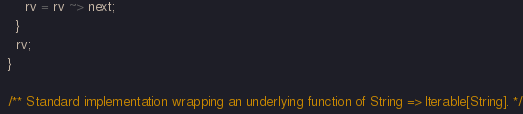<code> <loc_0><loc_0><loc_500><loc_500><_Scala_>      rv = rv ~> next;
    }
    rv;
  }

  /** Standard implementation wrapping an underlying function of String => Iterable[String]. */</code> 